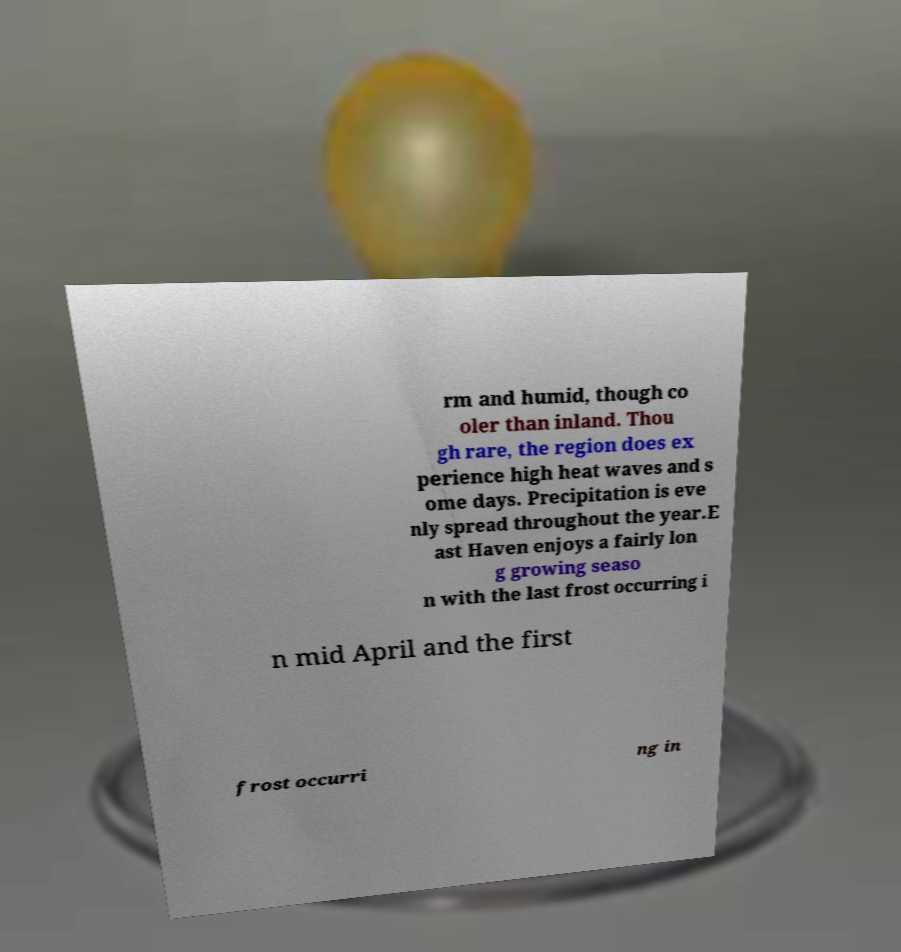For documentation purposes, I need the text within this image transcribed. Could you provide that? rm and humid, though co oler than inland. Thou gh rare, the region does ex perience high heat waves and s ome days. Precipitation is eve nly spread throughout the year.E ast Haven enjoys a fairly lon g growing seaso n with the last frost occurring i n mid April and the first frost occurri ng in 